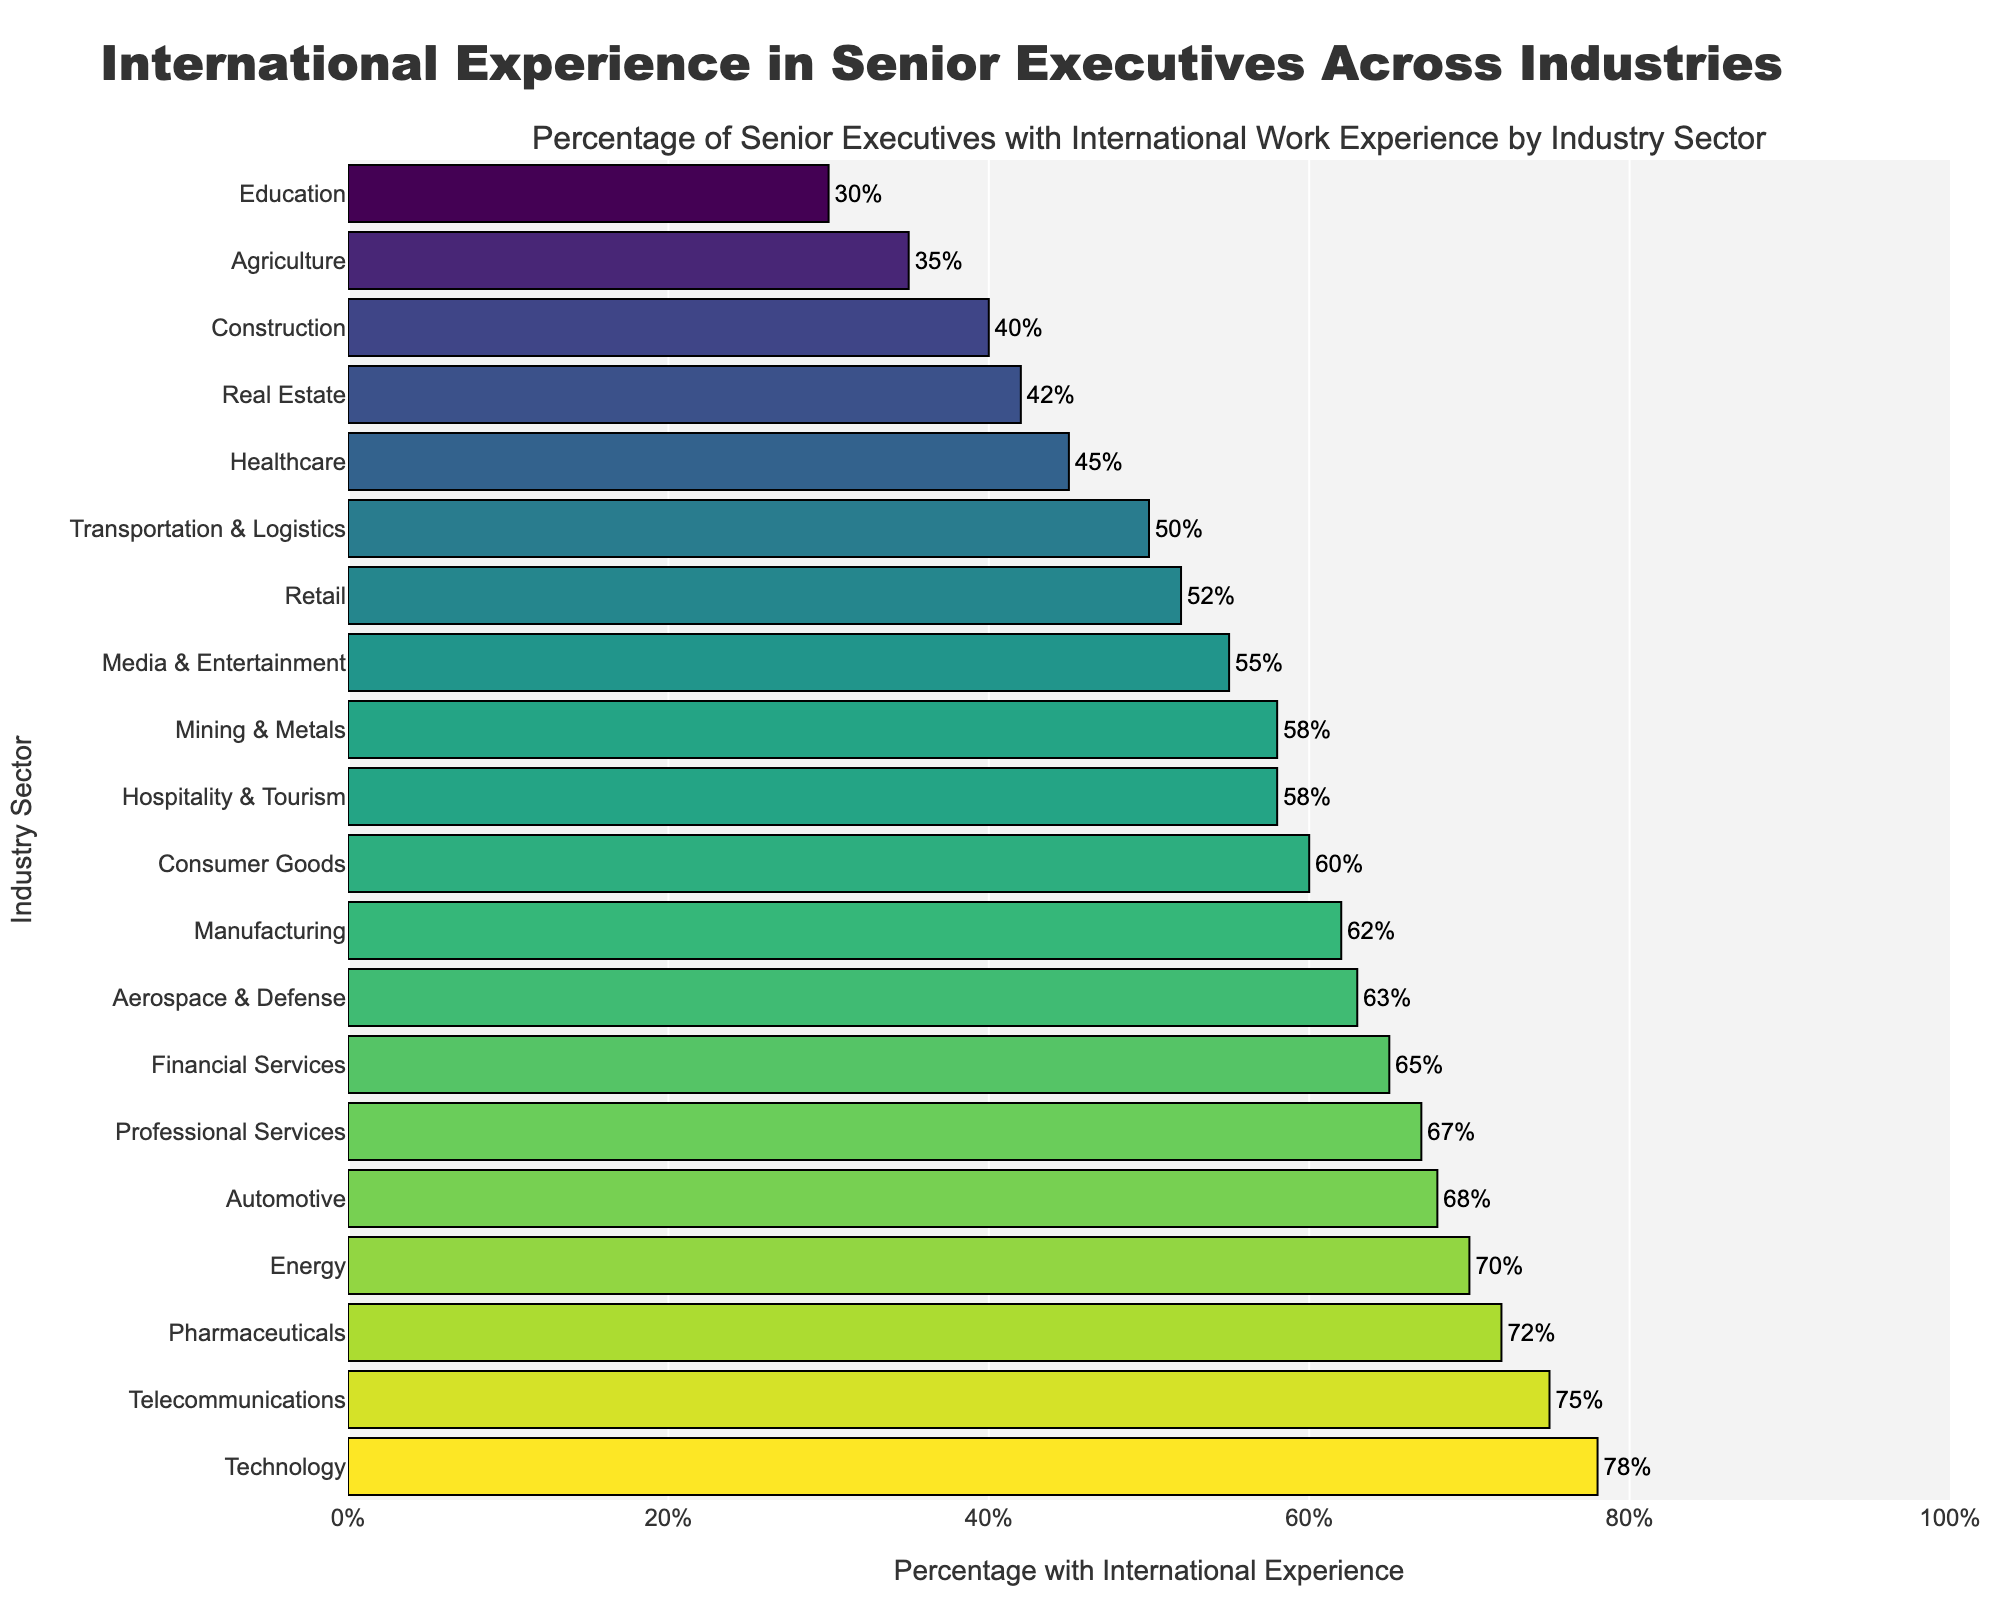Which industry sector has the highest percentage of senior executives with international work experience? The bar corresponding to Technology is the longest, indicating it has the highest percentage of executives with international experience.
Answer: Technology Which industry has a lower percentage of senior executives with international experience than the Financial Services sector but higher than the Retail sector? The bars for Automotive, Energy, and Telecommunications are between those for Financial Services and Retail.
Answer: Automotive List the top three industries with the highest percentage of senior executives with international work experience. The bars for Technology, Telecommunications, and Pharmaceuticals are the three longest on the chart.
Answer: Technology, Telecommunications, Pharmaceuticals Compare the percentage of senior executives with international work experience in Healthcare and Retail. Which one is higher? The bar for Retail is slightly longer than the bar for Healthcare, indicating a higher percentage.
Answer: Retail What is the total percentage of senior executives with international work experience in the Agriculture and Education sectors combined? The bars for Agriculture and Education are 35% and 30%, respectively. Combined, this is 35% + 30% = 65%.
Answer: 65% How does the percentage of senior executives with international work experience in Professional Services compare to that in Automotive? The bar for Professional Services is slightly shorter than the bar for Automotive.
Answer: Less than Which industry sector has the shortest bar, indicating the lowest percentage of senior executives with international work experience? The shortest bar corresponds to the Education sector.
Answer: Education What is the average percentage of senior executives with international work experience for the top five industries? The top five industries are Technology (78%), Telecommunications (75%), Pharmaceuticals (72%), Energy (70%), and Automotive (68%). The average is (78 + 75 + 72 + 70 + 68) / 5 = 72.6%.
Answer: 72.6% Is the percentage of senior executives with international experience in Media & Entertainment greater than or less than 60%? The bar for Media & Entertainment is at 55%, which is clearly less than 60%.
Answer: Less than Which industry has a more visually striking bar color, Agriculture or Aerospace & Defense, and why? The bar for Aerospace & Defense is colored with a gradient that appears lighter and more vibrant compared to the darker shade used for Agriculture, making it more visually striking.
Answer: Aerospace & Defense 